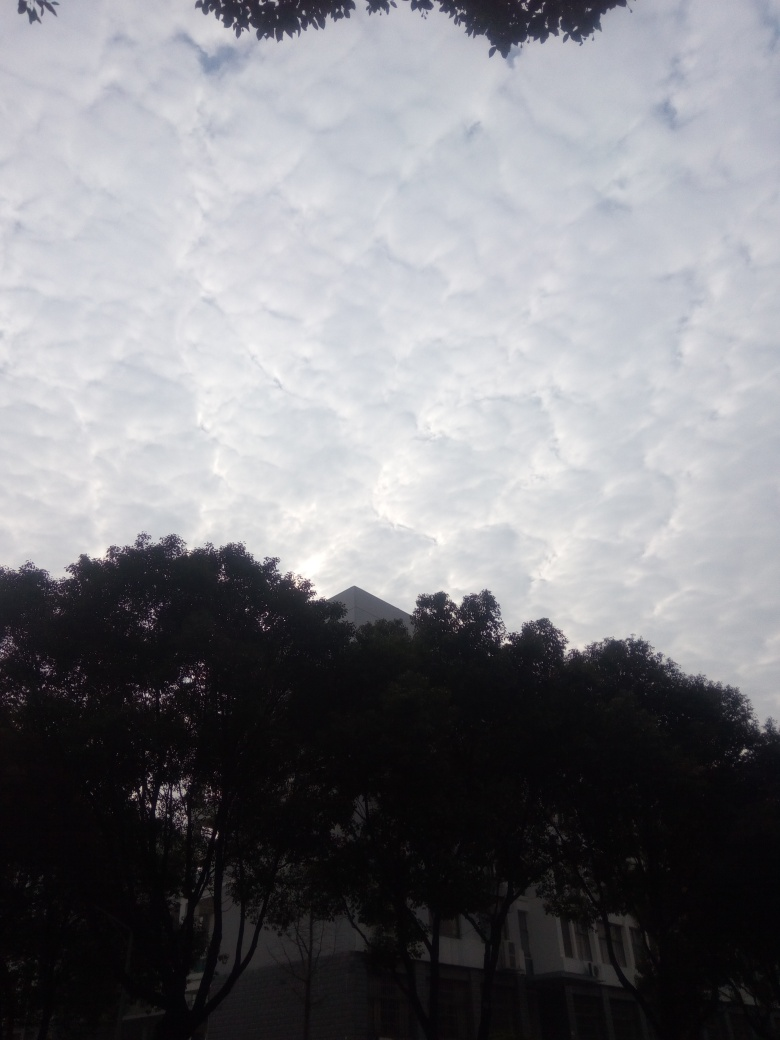What is the clarity of this photo?
A. Low clarity
B. Relatively high clarity
C. Moderate clarity
Answer with the option's letter from the given choices directly. The clarity of the photo can be considered to be relatively high as the details such as the patterns of the clouds, the outline of the building, and the silhouettes of the trees are quite distinguishable. However, the overall exposure of the image is on the darker side, which might affect the perception of clarity to a certain extent. 